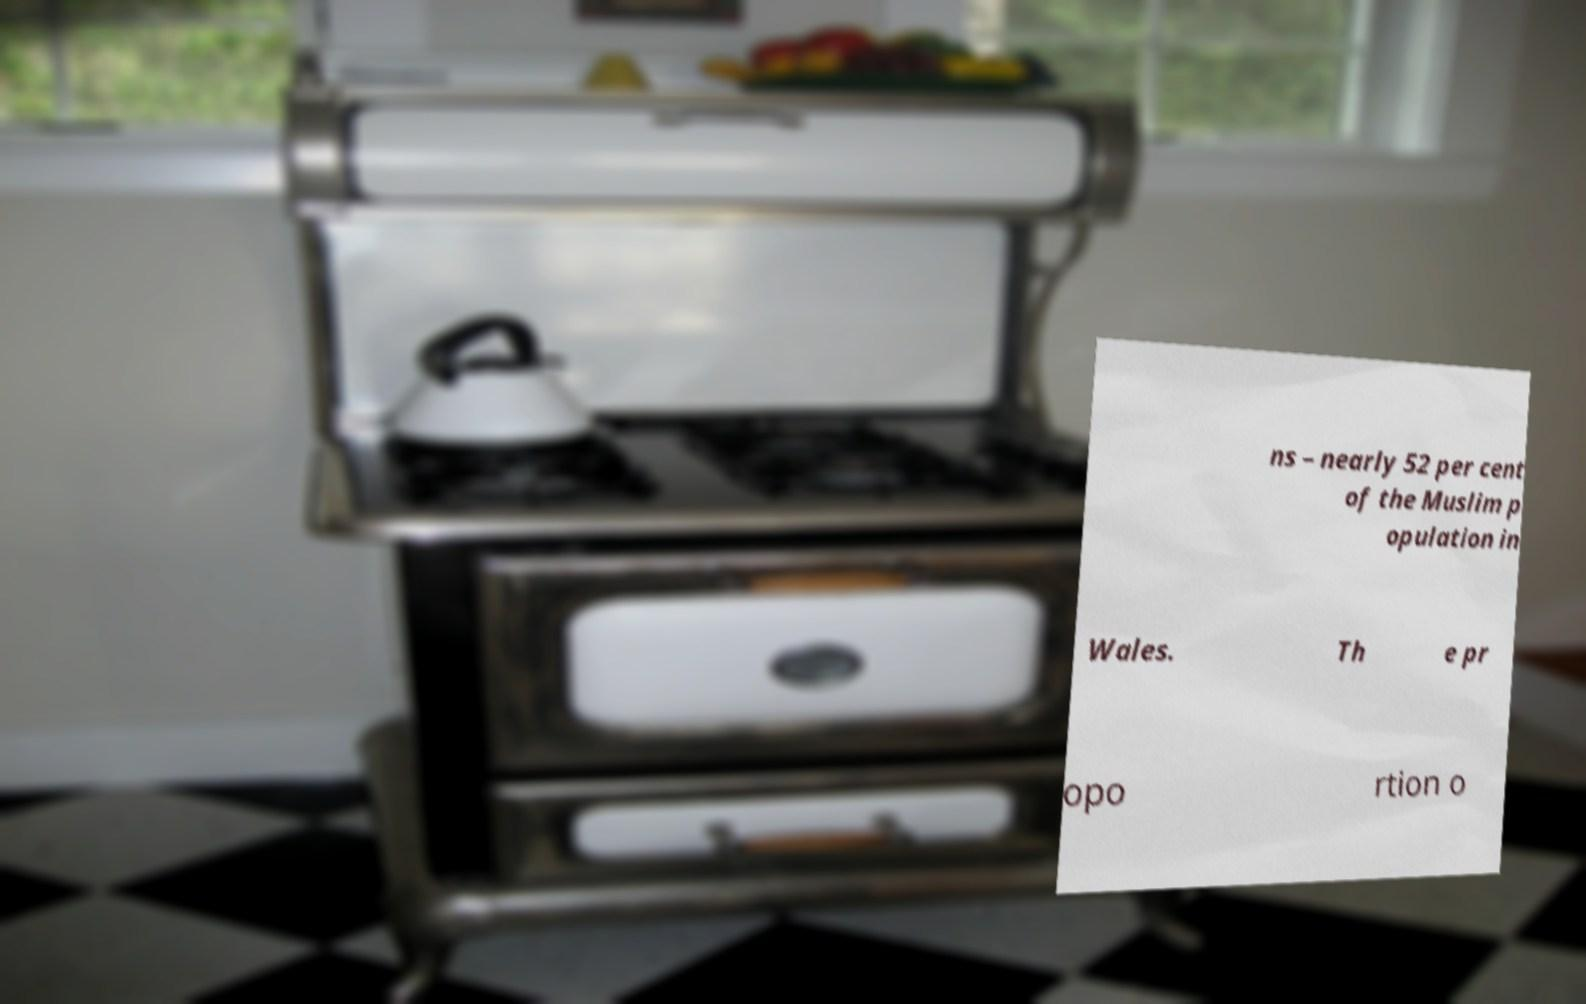Please read and relay the text visible in this image. What does it say? ns – nearly 52 per cent of the Muslim p opulation in Wales. Th e pr opo rtion o 